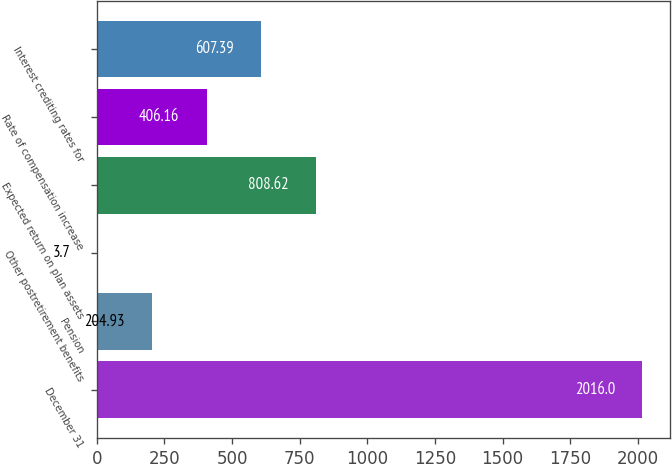Convert chart to OTSL. <chart><loc_0><loc_0><loc_500><loc_500><bar_chart><fcel>December 31<fcel>Pension<fcel>Other postretirement benefits<fcel>Expected return on plan assets<fcel>Rate of compensation increase<fcel>Interest crediting rates for<nl><fcel>2016<fcel>204.93<fcel>3.7<fcel>808.62<fcel>406.16<fcel>607.39<nl></chart> 